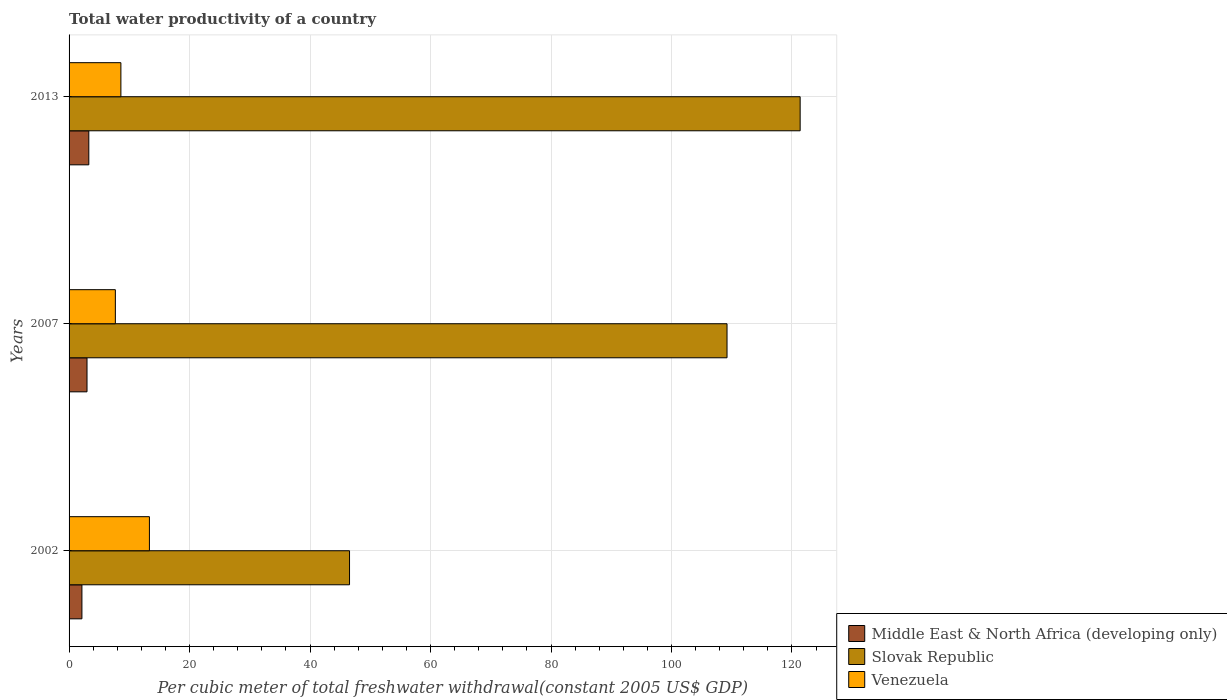How many different coloured bars are there?
Keep it short and to the point. 3. How many groups of bars are there?
Offer a terse response. 3. Are the number of bars per tick equal to the number of legend labels?
Keep it short and to the point. Yes. Are the number of bars on each tick of the Y-axis equal?
Give a very brief answer. Yes. How many bars are there on the 2nd tick from the top?
Provide a short and direct response. 3. What is the label of the 1st group of bars from the top?
Make the answer very short. 2013. What is the total water productivity in Middle East & North Africa (developing only) in 2013?
Offer a very short reply. 3.28. Across all years, what is the maximum total water productivity in Venezuela?
Make the answer very short. 13.34. Across all years, what is the minimum total water productivity in Venezuela?
Ensure brevity in your answer.  7.68. What is the total total water productivity in Middle East & North Africa (developing only) in the graph?
Your response must be concise. 8.39. What is the difference between the total water productivity in Middle East & North Africa (developing only) in 2002 and that in 2007?
Ensure brevity in your answer.  -0.84. What is the difference between the total water productivity in Venezuela in 2013 and the total water productivity in Middle East & North Africa (developing only) in 2002?
Give a very brief answer. 6.47. What is the average total water productivity in Venezuela per year?
Offer a very short reply. 9.87. In the year 2013, what is the difference between the total water productivity in Middle East & North Africa (developing only) and total water productivity in Venezuela?
Keep it short and to the point. -5.32. What is the ratio of the total water productivity in Venezuela in 2002 to that in 2007?
Keep it short and to the point. 1.74. Is the difference between the total water productivity in Middle East & North Africa (developing only) in 2007 and 2013 greater than the difference between the total water productivity in Venezuela in 2007 and 2013?
Offer a terse response. Yes. What is the difference between the highest and the second highest total water productivity in Venezuela?
Make the answer very short. 4.74. What is the difference between the highest and the lowest total water productivity in Middle East & North Africa (developing only)?
Provide a succinct answer. 1.14. In how many years, is the total water productivity in Venezuela greater than the average total water productivity in Venezuela taken over all years?
Keep it short and to the point. 1. Is the sum of the total water productivity in Middle East & North Africa (developing only) in 2002 and 2013 greater than the maximum total water productivity in Slovak Republic across all years?
Make the answer very short. No. What does the 1st bar from the top in 2007 represents?
Keep it short and to the point. Venezuela. What does the 1st bar from the bottom in 2013 represents?
Offer a terse response. Middle East & North Africa (developing only). How many bars are there?
Keep it short and to the point. 9. What is the difference between two consecutive major ticks on the X-axis?
Make the answer very short. 20. Are the values on the major ticks of X-axis written in scientific E-notation?
Your response must be concise. No. Does the graph contain grids?
Provide a succinct answer. Yes. How are the legend labels stacked?
Ensure brevity in your answer.  Vertical. What is the title of the graph?
Make the answer very short. Total water productivity of a country. What is the label or title of the X-axis?
Offer a very short reply. Per cubic meter of total freshwater withdrawal(constant 2005 US$ GDP). What is the Per cubic meter of total freshwater withdrawal(constant 2005 US$ GDP) in Middle East & North Africa (developing only) in 2002?
Offer a terse response. 2.13. What is the Per cubic meter of total freshwater withdrawal(constant 2005 US$ GDP) of Slovak Republic in 2002?
Give a very brief answer. 46.55. What is the Per cubic meter of total freshwater withdrawal(constant 2005 US$ GDP) in Venezuela in 2002?
Keep it short and to the point. 13.34. What is the Per cubic meter of total freshwater withdrawal(constant 2005 US$ GDP) of Middle East & North Africa (developing only) in 2007?
Your response must be concise. 2.98. What is the Per cubic meter of total freshwater withdrawal(constant 2005 US$ GDP) of Slovak Republic in 2007?
Your answer should be very brief. 109.22. What is the Per cubic meter of total freshwater withdrawal(constant 2005 US$ GDP) of Venezuela in 2007?
Provide a succinct answer. 7.68. What is the Per cubic meter of total freshwater withdrawal(constant 2005 US$ GDP) in Middle East & North Africa (developing only) in 2013?
Provide a short and direct response. 3.28. What is the Per cubic meter of total freshwater withdrawal(constant 2005 US$ GDP) of Slovak Republic in 2013?
Provide a short and direct response. 121.36. What is the Per cubic meter of total freshwater withdrawal(constant 2005 US$ GDP) in Venezuela in 2013?
Keep it short and to the point. 8.6. Across all years, what is the maximum Per cubic meter of total freshwater withdrawal(constant 2005 US$ GDP) in Middle East & North Africa (developing only)?
Your response must be concise. 3.28. Across all years, what is the maximum Per cubic meter of total freshwater withdrawal(constant 2005 US$ GDP) of Slovak Republic?
Make the answer very short. 121.36. Across all years, what is the maximum Per cubic meter of total freshwater withdrawal(constant 2005 US$ GDP) of Venezuela?
Offer a terse response. 13.34. Across all years, what is the minimum Per cubic meter of total freshwater withdrawal(constant 2005 US$ GDP) of Middle East & North Africa (developing only)?
Give a very brief answer. 2.13. Across all years, what is the minimum Per cubic meter of total freshwater withdrawal(constant 2005 US$ GDP) of Slovak Republic?
Your answer should be very brief. 46.55. Across all years, what is the minimum Per cubic meter of total freshwater withdrawal(constant 2005 US$ GDP) of Venezuela?
Keep it short and to the point. 7.68. What is the total Per cubic meter of total freshwater withdrawal(constant 2005 US$ GDP) in Middle East & North Africa (developing only) in the graph?
Your answer should be very brief. 8.39. What is the total Per cubic meter of total freshwater withdrawal(constant 2005 US$ GDP) in Slovak Republic in the graph?
Your answer should be very brief. 277.13. What is the total Per cubic meter of total freshwater withdrawal(constant 2005 US$ GDP) of Venezuela in the graph?
Give a very brief answer. 29.62. What is the difference between the Per cubic meter of total freshwater withdrawal(constant 2005 US$ GDP) of Middle East & North Africa (developing only) in 2002 and that in 2007?
Ensure brevity in your answer.  -0.84. What is the difference between the Per cubic meter of total freshwater withdrawal(constant 2005 US$ GDP) in Slovak Republic in 2002 and that in 2007?
Offer a terse response. -62.66. What is the difference between the Per cubic meter of total freshwater withdrawal(constant 2005 US$ GDP) of Venezuela in 2002 and that in 2007?
Make the answer very short. 5.65. What is the difference between the Per cubic meter of total freshwater withdrawal(constant 2005 US$ GDP) of Middle East & North Africa (developing only) in 2002 and that in 2013?
Your response must be concise. -1.14. What is the difference between the Per cubic meter of total freshwater withdrawal(constant 2005 US$ GDP) of Slovak Republic in 2002 and that in 2013?
Your response must be concise. -74.8. What is the difference between the Per cubic meter of total freshwater withdrawal(constant 2005 US$ GDP) in Venezuela in 2002 and that in 2013?
Keep it short and to the point. 4.74. What is the difference between the Per cubic meter of total freshwater withdrawal(constant 2005 US$ GDP) in Middle East & North Africa (developing only) in 2007 and that in 2013?
Offer a terse response. -0.3. What is the difference between the Per cubic meter of total freshwater withdrawal(constant 2005 US$ GDP) of Slovak Republic in 2007 and that in 2013?
Your response must be concise. -12.14. What is the difference between the Per cubic meter of total freshwater withdrawal(constant 2005 US$ GDP) in Venezuela in 2007 and that in 2013?
Your answer should be compact. -0.92. What is the difference between the Per cubic meter of total freshwater withdrawal(constant 2005 US$ GDP) in Middle East & North Africa (developing only) in 2002 and the Per cubic meter of total freshwater withdrawal(constant 2005 US$ GDP) in Slovak Republic in 2007?
Ensure brevity in your answer.  -107.08. What is the difference between the Per cubic meter of total freshwater withdrawal(constant 2005 US$ GDP) of Middle East & North Africa (developing only) in 2002 and the Per cubic meter of total freshwater withdrawal(constant 2005 US$ GDP) of Venezuela in 2007?
Ensure brevity in your answer.  -5.55. What is the difference between the Per cubic meter of total freshwater withdrawal(constant 2005 US$ GDP) of Slovak Republic in 2002 and the Per cubic meter of total freshwater withdrawal(constant 2005 US$ GDP) of Venezuela in 2007?
Offer a very short reply. 38.87. What is the difference between the Per cubic meter of total freshwater withdrawal(constant 2005 US$ GDP) in Middle East & North Africa (developing only) in 2002 and the Per cubic meter of total freshwater withdrawal(constant 2005 US$ GDP) in Slovak Republic in 2013?
Offer a terse response. -119.22. What is the difference between the Per cubic meter of total freshwater withdrawal(constant 2005 US$ GDP) in Middle East & North Africa (developing only) in 2002 and the Per cubic meter of total freshwater withdrawal(constant 2005 US$ GDP) in Venezuela in 2013?
Make the answer very short. -6.47. What is the difference between the Per cubic meter of total freshwater withdrawal(constant 2005 US$ GDP) in Slovak Republic in 2002 and the Per cubic meter of total freshwater withdrawal(constant 2005 US$ GDP) in Venezuela in 2013?
Give a very brief answer. 37.95. What is the difference between the Per cubic meter of total freshwater withdrawal(constant 2005 US$ GDP) in Middle East & North Africa (developing only) in 2007 and the Per cubic meter of total freshwater withdrawal(constant 2005 US$ GDP) in Slovak Republic in 2013?
Provide a short and direct response. -118.38. What is the difference between the Per cubic meter of total freshwater withdrawal(constant 2005 US$ GDP) of Middle East & North Africa (developing only) in 2007 and the Per cubic meter of total freshwater withdrawal(constant 2005 US$ GDP) of Venezuela in 2013?
Provide a succinct answer. -5.62. What is the difference between the Per cubic meter of total freshwater withdrawal(constant 2005 US$ GDP) in Slovak Republic in 2007 and the Per cubic meter of total freshwater withdrawal(constant 2005 US$ GDP) in Venezuela in 2013?
Ensure brevity in your answer.  100.62. What is the average Per cubic meter of total freshwater withdrawal(constant 2005 US$ GDP) in Middle East & North Africa (developing only) per year?
Your response must be concise. 2.8. What is the average Per cubic meter of total freshwater withdrawal(constant 2005 US$ GDP) in Slovak Republic per year?
Offer a very short reply. 92.38. What is the average Per cubic meter of total freshwater withdrawal(constant 2005 US$ GDP) of Venezuela per year?
Your answer should be compact. 9.87. In the year 2002, what is the difference between the Per cubic meter of total freshwater withdrawal(constant 2005 US$ GDP) of Middle East & North Africa (developing only) and Per cubic meter of total freshwater withdrawal(constant 2005 US$ GDP) of Slovak Republic?
Your response must be concise. -44.42. In the year 2002, what is the difference between the Per cubic meter of total freshwater withdrawal(constant 2005 US$ GDP) of Middle East & North Africa (developing only) and Per cubic meter of total freshwater withdrawal(constant 2005 US$ GDP) of Venezuela?
Your response must be concise. -11.2. In the year 2002, what is the difference between the Per cubic meter of total freshwater withdrawal(constant 2005 US$ GDP) in Slovak Republic and Per cubic meter of total freshwater withdrawal(constant 2005 US$ GDP) in Venezuela?
Your answer should be very brief. 33.22. In the year 2007, what is the difference between the Per cubic meter of total freshwater withdrawal(constant 2005 US$ GDP) in Middle East & North Africa (developing only) and Per cubic meter of total freshwater withdrawal(constant 2005 US$ GDP) in Slovak Republic?
Your answer should be very brief. -106.24. In the year 2007, what is the difference between the Per cubic meter of total freshwater withdrawal(constant 2005 US$ GDP) of Middle East & North Africa (developing only) and Per cubic meter of total freshwater withdrawal(constant 2005 US$ GDP) of Venezuela?
Provide a short and direct response. -4.7. In the year 2007, what is the difference between the Per cubic meter of total freshwater withdrawal(constant 2005 US$ GDP) of Slovak Republic and Per cubic meter of total freshwater withdrawal(constant 2005 US$ GDP) of Venezuela?
Your response must be concise. 101.53. In the year 2013, what is the difference between the Per cubic meter of total freshwater withdrawal(constant 2005 US$ GDP) in Middle East & North Africa (developing only) and Per cubic meter of total freshwater withdrawal(constant 2005 US$ GDP) in Slovak Republic?
Make the answer very short. -118.08. In the year 2013, what is the difference between the Per cubic meter of total freshwater withdrawal(constant 2005 US$ GDP) of Middle East & North Africa (developing only) and Per cubic meter of total freshwater withdrawal(constant 2005 US$ GDP) of Venezuela?
Provide a short and direct response. -5.32. In the year 2013, what is the difference between the Per cubic meter of total freshwater withdrawal(constant 2005 US$ GDP) in Slovak Republic and Per cubic meter of total freshwater withdrawal(constant 2005 US$ GDP) in Venezuela?
Keep it short and to the point. 112.76. What is the ratio of the Per cubic meter of total freshwater withdrawal(constant 2005 US$ GDP) of Middle East & North Africa (developing only) in 2002 to that in 2007?
Give a very brief answer. 0.72. What is the ratio of the Per cubic meter of total freshwater withdrawal(constant 2005 US$ GDP) in Slovak Republic in 2002 to that in 2007?
Provide a succinct answer. 0.43. What is the ratio of the Per cubic meter of total freshwater withdrawal(constant 2005 US$ GDP) in Venezuela in 2002 to that in 2007?
Your answer should be compact. 1.74. What is the ratio of the Per cubic meter of total freshwater withdrawal(constant 2005 US$ GDP) of Middle East & North Africa (developing only) in 2002 to that in 2013?
Ensure brevity in your answer.  0.65. What is the ratio of the Per cubic meter of total freshwater withdrawal(constant 2005 US$ GDP) in Slovak Republic in 2002 to that in 2013?
Make the answer very short. 0.38. What is the ratio of the Per cubic meter of total freshwater withdrawal(constant 2005 US$ GDP) in Venezuela in 2002 to that in 2013?
Your answer should be very brief. 1.55. What is the ratio of the Per cubic meter of total freshwater withdrawal(constant 2005 US$ GDP) of Middle East & North Africa (developing only) in 2007 to that in 2013?
Offer a terse response. 0.91. What is the ratio of the Per cubic meter of total freshwater withdrawal(constant 2005 US$ GDP) in Slovak Republic in 2007 to that in 2013?
Your answer should be compact. 0.9. What is the ratio of the Per cubic meter of total freshwater withdrawal(constant 2005 US$ GDP) of Venezuela in 2007 to that in 2013?
Your answer should be very brief. 0.89. What is the difference between the highest and the second highest Per cubic meter of total freshwater withdrawal(constant 2005 US$ GDP) in Middle East & North Africa (developing only)?
Ensure brevity in your answer.  0.3. What is the difference between the highest and the second highest Per cubic meter of total freshwater withdrawal(constant 2005 US$ GDP) of Slovak Republic?
Provide a short and direct response. 12.14. What is the difference between the highest and the second highest Per cubic meter of total freshwater withdrawal(constant 2005 US$ GDP) of Venezuela?
Ensure brevity in your answer.  4.74. What is the difference between the highest and the lowest Per cubic meter of total freshwater withdrawal(constant 2005 US$ GDP) in Middle East & North Africa (developing only)?
Make the answer very short. 1.14. What is the difference between the highest and the lowest Per cubic meter of total freshwater withdrawal(constant 2005 US$ GDP) in Slovak Republic?
Offer a terse response. 74.8. What is the difference between the highest and the lowest Per cubic meter of total freshwater withdrawal(constant 2005 US$ GDP) in Venezuela?
Make the answer very short. 5.65. 